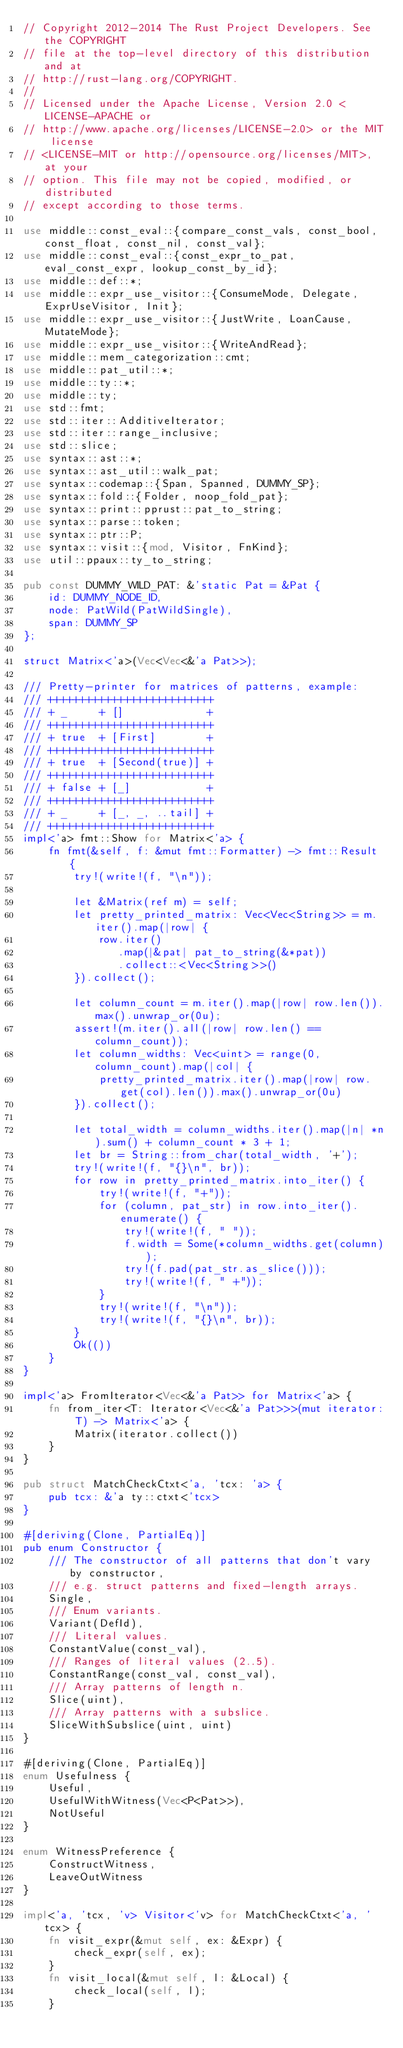Convert code to text. <code><loc_0><loc_0><loc_500><loc_500><_Rust_>// Copyright 2012-2014 The Rust Project Developers. See the COPYRIGHT
// file at the top-level directory of this distribution and at
// http://rust-lang.org/COPYRIGHT.
//
// Licensed under the Apache License, Version 2.0 <LICENSE-APACHE or
// http://www.apache.org/licenses/LICENSE-2.0> or the MIT license
// <LICENSE-MIT or http://opensource.org/licenses/MIT>, at your
// option. This file may not be copied, modified, or distributed
// except according to those terms.

use middle::const_eval::{compare_const_vals, const_bool, const_float, const_nil, const_val};
use middle::const_eval::{const_expr_to_pat, eval_const_expr, lookup_const_by_id};
use middle::def::*;
use middle::expr_use_visitor::{ConsumeMode, Delegate, ExprUseVisitor, Init};
use middle::expr_use_visitor::{JustWrite, LoanCause, MutateMode};
use middle::expr_use_visitor::{WriteAndRead};
use middle::mem_categorization::cmt;
use middle::pat_util::*;
use middle::ty::*;
use middle::ty;
use std::fmt;
use std::iter::AdditiveIterator;
use std::iter::range_inclusive;
use std::slice;
use syntax::ast::*;
use syntax::ast_util::walk_pat;
use syntax::codemap::{Span, Spanned, DUMMY_SP};
use syntax::fold::{Folder, noop_fold_pat};
use syntax::print::pprust::pat_to_string;
use syntax::parse::token;
use syntax::ptr::P;
use syntax::visit::{mod, Visitor, FnKind};
use util::ppaux::ty_to_string;

pub const DUMMY_WILD_PAT: &'static Pat = &Pat {
    id: DUMMY_NODE_ID,
    node: PatWild(PatWildSingle),
    span: DUMMY_SP
};

struct Matrix<'a>(Vec<Vec<&'a Pat>>);

/// Pretty-printer for matrices of patterns, example:
/// ++++++++++++++++++++++++++
/// + _     + []             +
/// ++++++++++++++++++++++++++
/// + true  + [First]        +
/// ++++++++++++++++++++++++++
/// + true  + [Second(true)] +
/// ++++++++++++++++++++++++++
/// + false + [_]            +
/// ++++++++++++++++++++++++++
/// + _     + [_, _, ..tail] +
/// ++++++++++++++++++++++++++
impl<'a> fmt::Show for Matrix<'a> {
    fn fmt(&self, f: &mut fmt::Formatter) -> fmt::Result {
        try!(write!(f, "\n"));

        let &Matrix(ref m) = self;
        let pretty_printed_matrix: Vec<Vec<String>> = m.iter().map(|row| {
            row.iter()
               .map(|&pat| pat_to_string(&*pat))
               .collect::<Vec<String>>()
        }).collect();

        let column_count = m.iter().map(|row| row.len()).max().unwrap_or(0u);
        assert!(m.iter().all(|row| row.len() == column_count));
        let column_widths: Vec<uint> = range(0, column_count).map(|col| {
            pretty_printed_matrix.iter().map(|row| row.get(col).len()).max().unwrap_or(0u)
        }).collect();

        let total_width = column_widths.iter().map(|n| *n).sum() + column_count * 3 + 1;
        let br = String::from_char(total_width, '+');
        try!(write!(f, "{}\n", br));
        for row in pretty_printed_matrix.into_iter() {
            try!(write!(f, "+"));
            for (column, pat_str) in row.into_iter().enumerate() {
                try!(write!(f, " "));
                f.width = Some(*column_widths.get(column));
                try!(f.pad(pat_str.as_slice()));
                try!(write!(f, " +"));
            }
            try!(write!(f, "\n"));
            try!(write!(f, "{}\n", br));
        }
        Ok(())
    }
}

impl<'a> FromIterator<Vec<&'a Pat>> for Matrix<'a> {
    fn from_iter<T: Iterator<Vec<&'a Pat>>>(mut iterator: T) -> Matrix<'a> {
        Matrix(iterator.collect())
    }
}

pub struct MatchCheckCtxt<'a, 'tcx: 'a> {
    pub tcx: &'a ty::ctxt<'tcx>
}

#[deriving(Clone, PartialEq)]
pub enum Constructor {
    /// The constructor of all patterns that don't vary by constructor,
    /// e.g. struct patterns and fixed-length arrays.
    Single,
    /// Enum variants.
    Variant(DefId),
    /// Literal values.
    ConstantValue(const_val),
    /// Ranges of literal values (2..5).
    ConstantRange(const_val, const_val),
    /// Array patterns of length n.
    Slice(uint),
    /// Array patterns with a subslice.
    SliceWithSubslice(uint, uint)
}

#[deriving(Clone, PartialEq)]
enum Usefulness {
    Useful,
    UsefulWithWitness(Vec<P<Pat>>),
    NotUseful
}

enum WitnessPreference {
    ConstructWitness,
    LeaveOutWitness
}

impl<'a, 'tcx, 'v> Visitor<'v> for MatchCheckCtxt<'a, 'tcx> {
    fn visit_expr(&mut self, ex: &Expr) {
        check_expr(self, ex);
    }
    fn visit_local(&mut self, l: &Local) {
        check_local(self, l);
    }</code> 